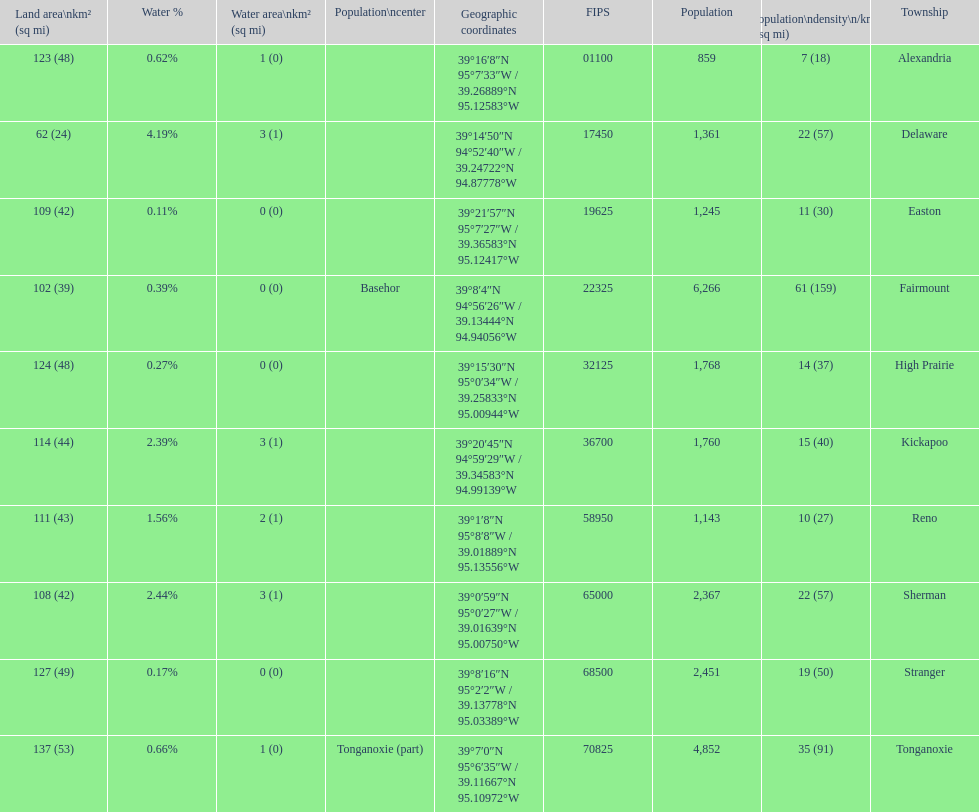How many townships have populations over 2,000? 4. 